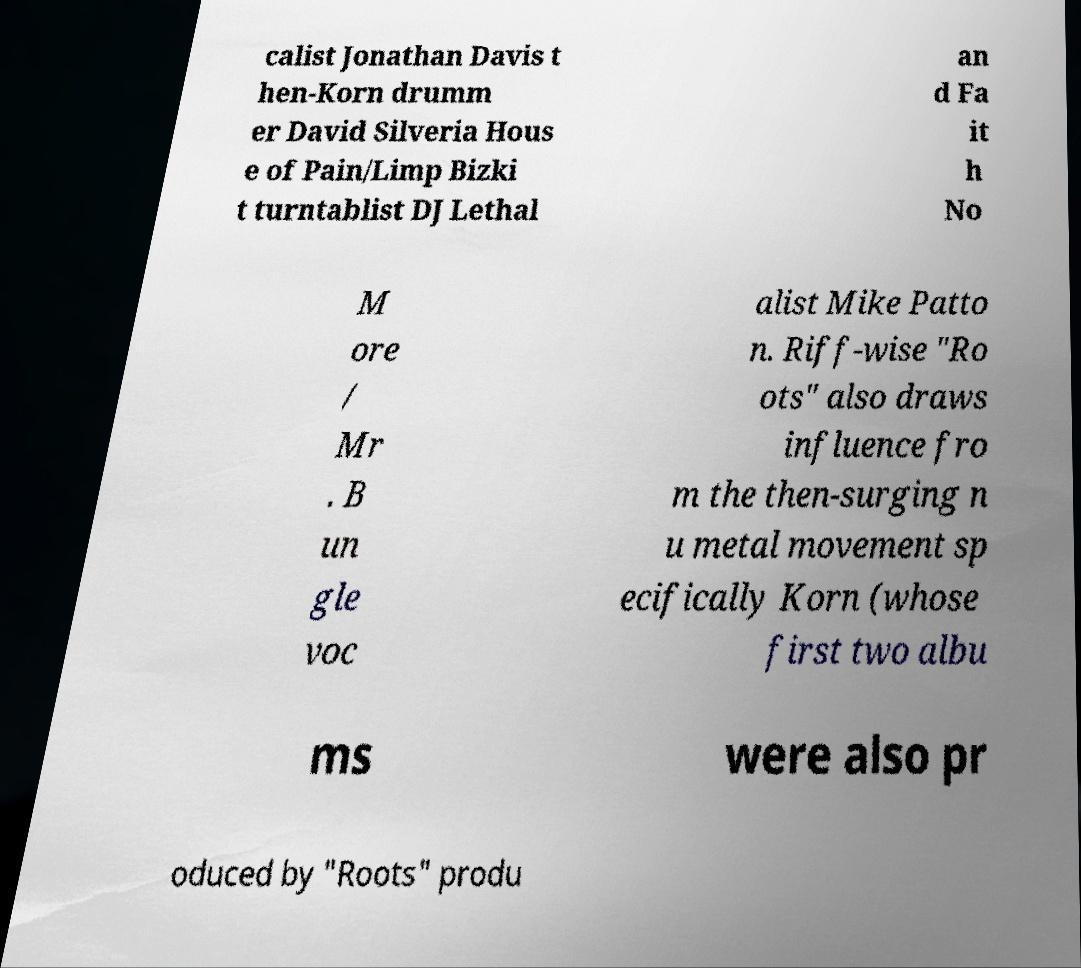Please identify and transcribe the text found in this image. calist Jonathan Davis t hen-Korn drumm er David Silveria Hous e of Pain/Limp Bizki t turntablist DJ Lethal an d Fa it h No M ore / Mr . B un gle voc alist Mike Patto n. Riff-wise "Ro ots" also draws influence fro m the then-surging n u metal movement sp ecifically Korn (whose first two albu ms were also pr oduced by "Roots" produ 